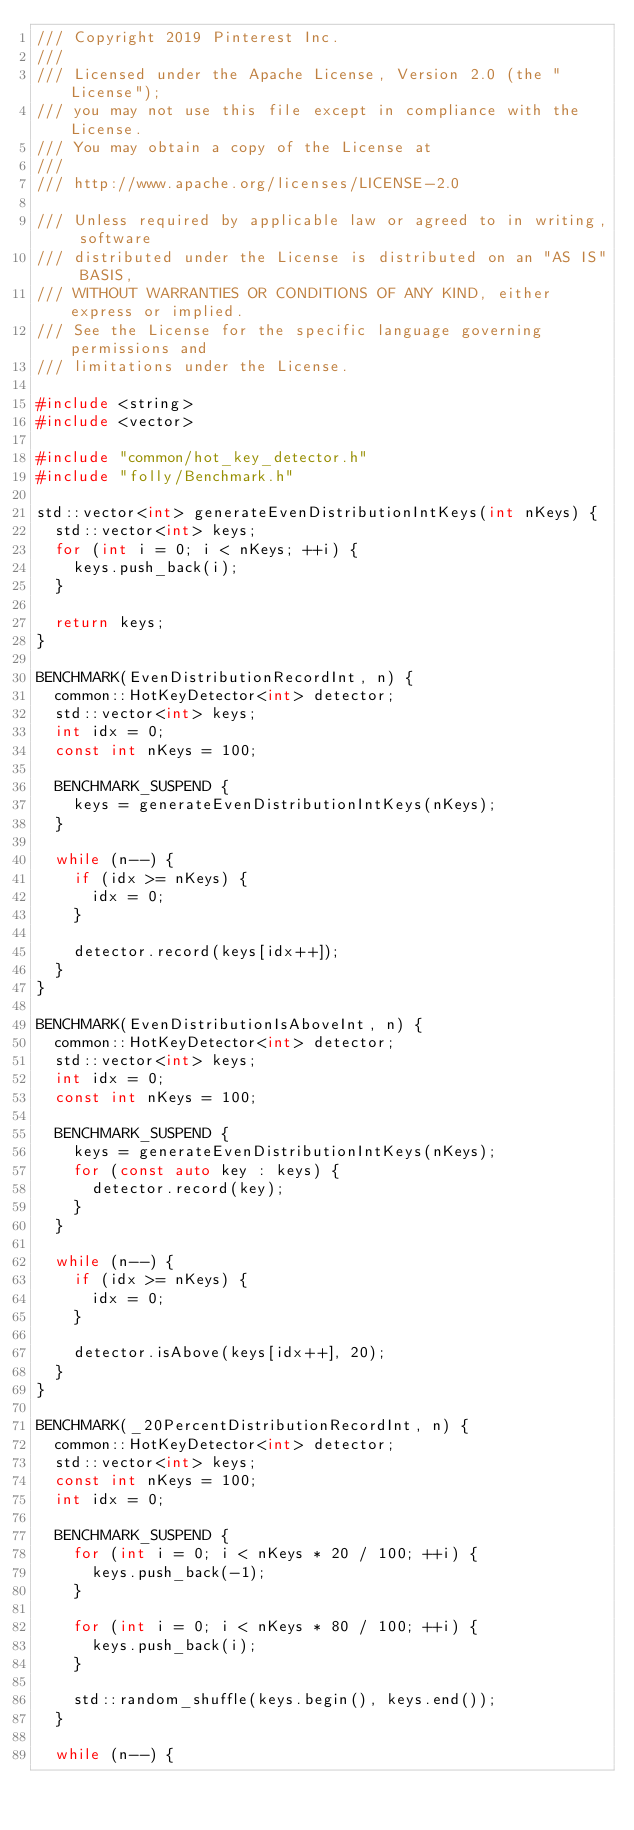<code> <loc_0><loc_0><loc_500><loc_500><_C++_>/// Copyright 2019 Pinterest Inc.
///
/// Licensed under the Apache License, Version 2.0 (the "License");
/// you may not use this file except in compliance with the License.
/// You may obtain a copy of the License at
///
/// http://www.apache.org/licenses/LICENSE-2.0

/// Unless required by applicable law or agreed to in writing, software
/// distributed under the License is distributed on an "AS IS" BASIS,
/// WITHOUT WARRANTIES OR CONDITIONS OF ANY KIND, either express or implied.
/// See the License for the specific language governing permissions and
/// limitations under the License.

#include <string>
#include <vector>

#include "common/hot_key_detector.h"
#include "folly/Benchmark.h"

std::vector<int> generateEvenDistributionIntKeys(int nKeys) {
  std::vector<int> keys;
  for (int i = 0; i < nKeys; ++i) {
    keys.push_back(i);
  }

  return keys;
}

BENCHMARK(EvenDistributionRecordInt, n) {
  common::HotKeyDetector<int> detector;
  std::vector<int> keys;
  int idx = 0;
  const int nKeys = 100;

  BENCHMARK_SUSPEND {
    keys = generateEvenDistributionIntKeys(nKeys);
  }

  while (n--) {
    if (idx >= nKeys) {
      idx = 0;
    }

    detector.record(keys[idx++]);
  }
}

BENCHMARK(EvenDistributionIsAboveInt, n) {
  common::HotKeyDetector<int> detector;
  std::vector<int> keys;
  int idx = 0;
  const int nKeys = 100;

  BENCHMARK_SUSPEND {
    keys = generateEvenDistributionIntKeys(nKeys);
    for (const auto key : keys) {
      detector.record(key);
    }
  }

  while (n--) {
    if (idx >= nKeys) {
      idx = 0;
    }

    detector.isAbove(keys[idx++], 20);
  }
}

BENCHMARK(_20PercentDistributionRecordInt, n) {
  common::HotKeyDetector<int> detector;
  std::vector<int> keys;
  const int nKeys = 100;
  int idx = 0;

  BENCHMARK_SUSPEND {
    for (int i = 0; i < nKeys * 20 / 100; ++i) {
      keys.push_back(-1);
    }

    for (int i = 0; i < nKeys * 80 / 100; ++i) {
      keys.push_back(i);
    }

    std::random_shuffle(keys.begin(), keys.end());
  }

  while (n--) {</code> 